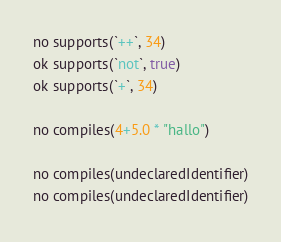Convert code to text. <code><loc_0><loc_0><loc_500><loc_500><_Nim_>no supports(`++`, 34)
ok supports(`not`, true)
ok supports(`+`, 34)

no compiles(4+5.0 * "hallo")

no compiles(undeclaredIdentifier)
no compiles(undeclaredIdentifier)
</code> 